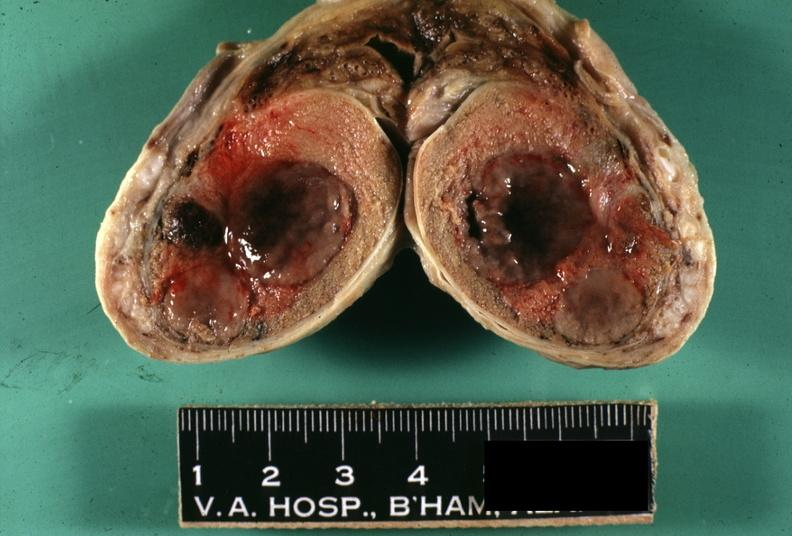s testicle present?
Answer the question using a single word or phrase. Yes 